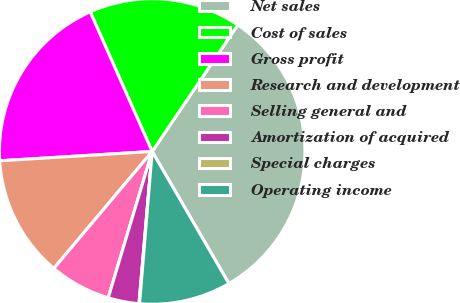Convert chart. <chart><loc_0><loc_0><loc_500><loc_500><pie_chart><fcel>Net sales<fcel>Cost of sales<fcel>Gross profit<fcel>Research and development<fcel>Selling general and<fcel>Amortization of acquired<fcel>Special charges<fcel>Operating income<nl><fcel>32.16%<fcel>16.11%<fcel>19.32%<fcel>12.9%<fcel>6.48%<fcel>3.27%<fcel>0.06%<fcel>9.69%<nl></chart> 